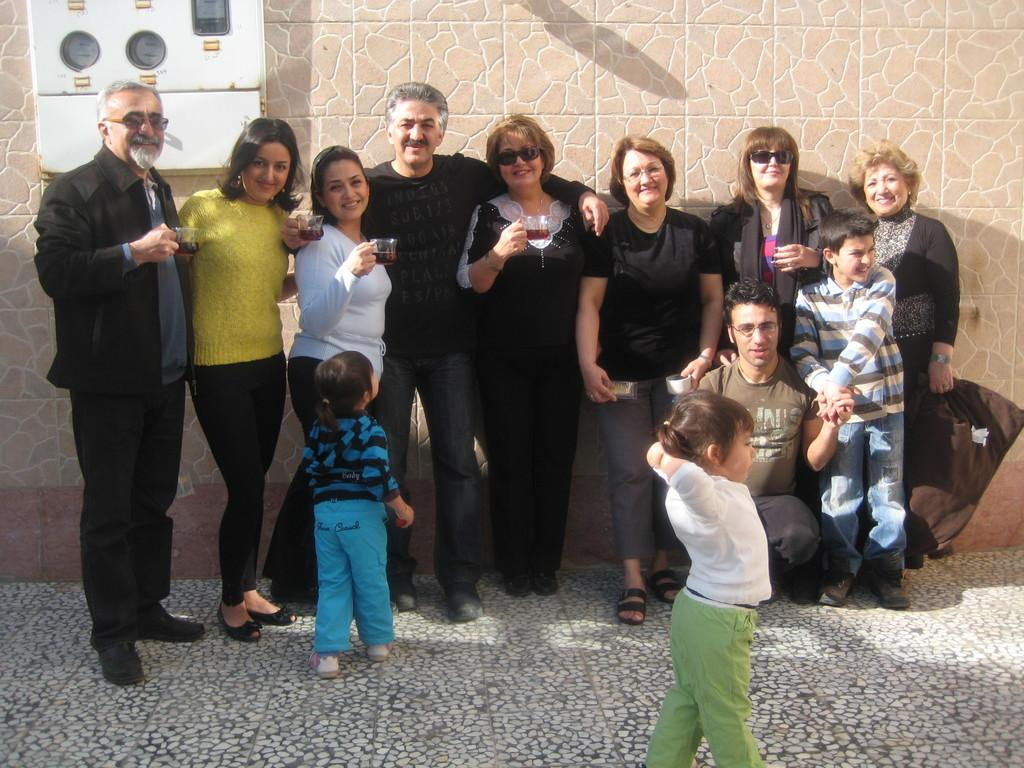What are the people in the image doing? The people in the image are standing on the floor and holding cups. What can be seen on the wall in the image? There is an object on the wall in the image. Can you describe the wall in the image? The wall is visible in the image. Are there any ants crawling on the cups in the image? There is no indication of ants in the image; the focus is on the people holding cups. What is the purpose of the protest in the image? There is no protest depicted in the image; it features people holding cups and a wall with an object on it. 